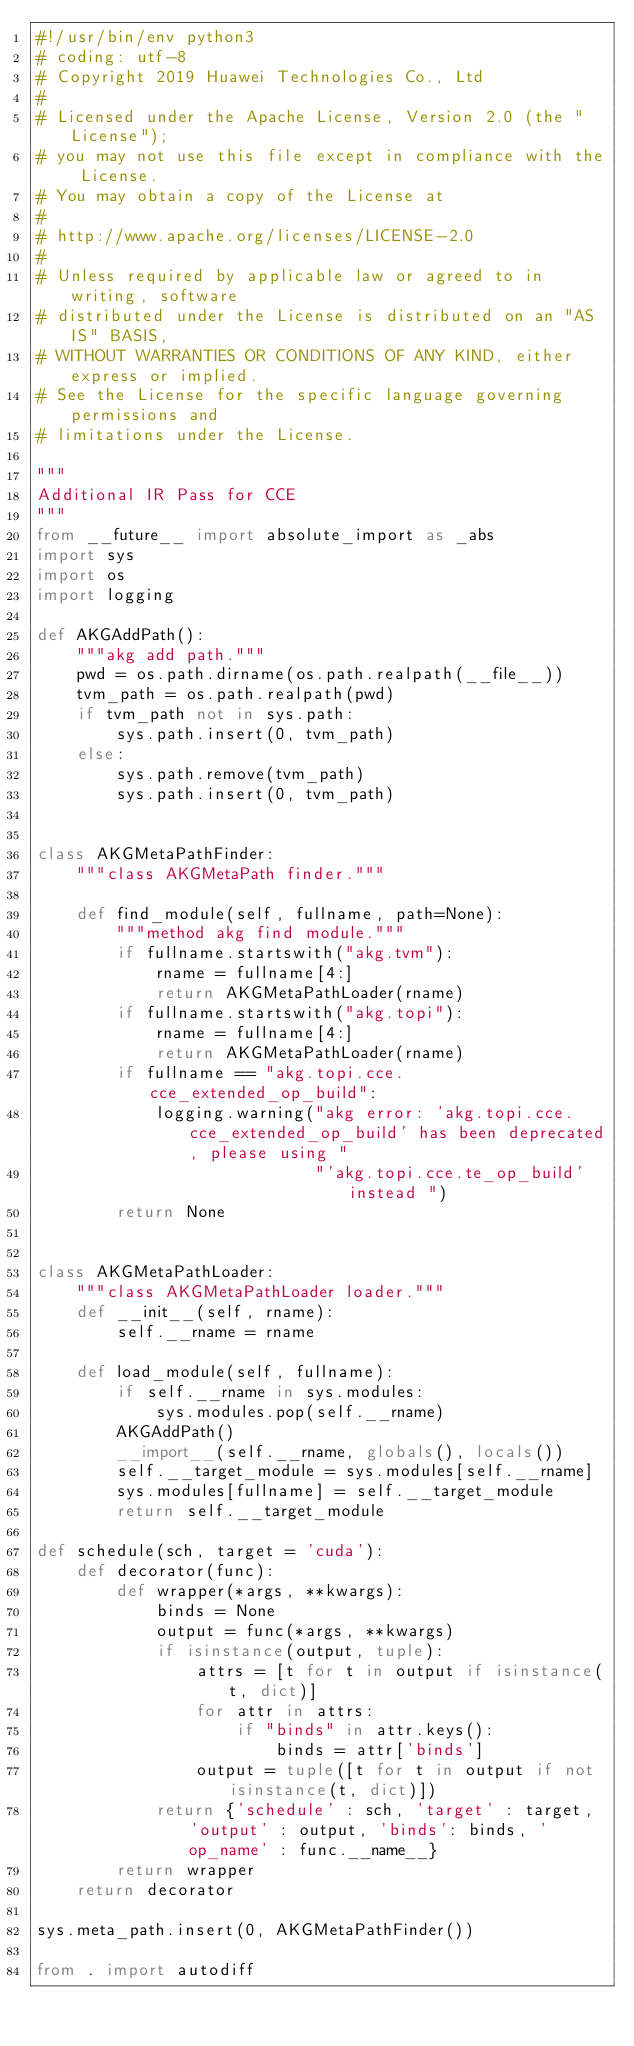<code> <loc_0><loc_0><loc_500><loc_500><_Python_>#!/usr/bin/env python3
# coding: utf-8
# Copyright 2019 Huawei Technologies Co., Ltd
#
# Licensed under the Apache License, Version 2.0 (the "License");
# you may not use this file except in compliance with the License.
# You may obtain a copy of the License at
#
# http://www.apache.org/licenses/LICENSE-2.0
#
# Unless required by applicable law or agreed to in writing, software
# distributed under the License is distributed on an "AS IS" BASIS,
# WITHOUT WARRANTIES OR CONDITIONS OF ANY KIND, either express or implied.
# See the License for the specific language governing permissions and
# limitations under the License.

"""
Additional IR Pass for CCE
"""
from __future__ import absolute_import as _abs
import sys
import os
import logging

def AKGAddPath():
    """akg add path."""
    pwd = os.path.dirname(os.path.realpath(__file__))
    tvm_path = os.path.realpath(pwd)
    if tvm_path not in sys.path:
        sys.path.insert(0, tvm_path)
    else:
        sys.path.remove(tvm_path)
        sys.path.insert(0, tvm_path)


class AKGMetaPathFinder:
    """class AKGMetaPath finder."""

    def find_module(self, fullname, path=None):
        """method akg find module."""
        if fullname.startswith("akg.tvm"):
            rname = fullname[4:]
            return AKGMetaPathLoader(rname)
        if fullname.startswith("akg.topi"):
            rname = fullname[4:]
            return AKGMetaPathLoader(rname)
        if fullname == "akg.topi.cce.cce_extended_op_build":
            logging.warning("akg error: 'akg.topi.cce.cce_extended_op_build' has been deprecated, please using "
                            "'akg.topi.cce.te_op_build' instead ")
        return None


class AKGMetaPathLoader:
    """class AKGMetaPathLoader loader."""
    def __init__(self, rname):
        self.__rname = rname

    def load_module(self, fullname):
        if self.__rname in sys.modules:
            sys.modules.pop(self.__rname)
        AKGAddPath()
        __import__(self.__rname, globals(), locals())
        self.__target_module = sys.modules[self.__rname]
        sys.modules[fullname] = self.__target_module
        return self.__target_module

def schedule(sch, target = 'cuda'):
    def decorator(func):
        def wrapper(*args, **kwargs):
            binds = None
            output = func(*args, **kwargs)
            if isinstance(output, tuple):
                attrs = [t for t in output if isinstance(t, dict)]
                for attr in attrs:
                    if "binds" in attr.keys():
                        binds = attr['binds']
                output = tuple([t for t in output if not isinstance(t, dict)])
            return {'schedule' : sch, 'target' : target, 'output' : output, 'binds': binds, 'op_name' : func.__name__}
        return wrapper
    return decorator

sys.meta_path.insert(0, AKGMetaPathFinder())

from . import autodiff</code> 